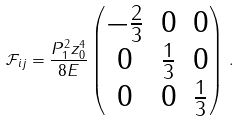<formula> <loc_0><loc_0><loc_500><loc_500>\mathcal { F } _ { i j } = \frac { P _ { 1 } ^ { 2 } z _ { 0 } ^ { 4 } } { 8 E } \begin{pmatrix} - \frac { 2 } { 3 } & 0 & 0 \\ 0 & \frac { 1 } { 3 } & 0 \\ 0 & 0 & \frac { 1 } { 3 } \end{pmatrix} \, .</formula> 